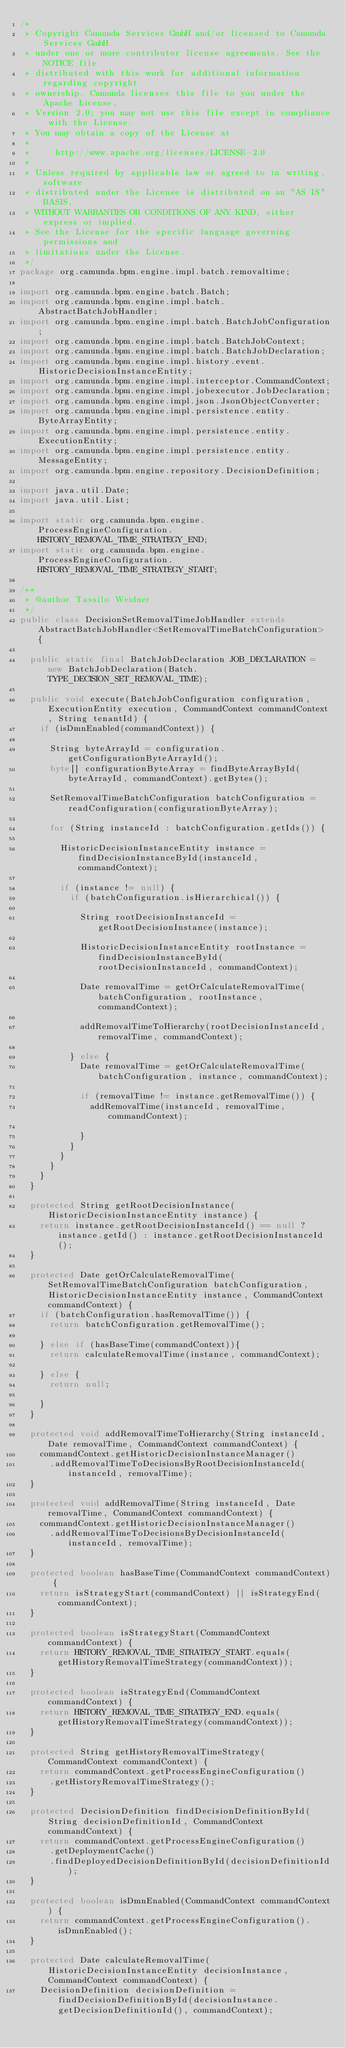Convert code to text. <code><loc_0><loc_0><loc_500><loc_500><_Java_>/*
 * Copyright Camunda Services GmbH and/or licensed to Camunda Services GmbH
 * under one or more contributor license agreements. See the NOTICE file
 * distributed with this work for additional information regarding copyright
 * ownership. Camunda licenses this file to you under the Apache License,
 * Version 2.0; you may not use this file except in compliance with the License.
 * You may obtain a copy of the License at
 *
 *     http://www.apache.org/licenses/LICENSE-2.0
 *
 * Unless required by applicable law or agreed to in writing, software
 * distributed under the License is distributed on an "AS IS" BASIS,
 * WITHOUT WARRANTIES OR CONDITIONS OF ANY KIND, either express or implied.
 * See the License for the specific language governing permissions and
 * limitations under the License.
 */
package org.camunda.bpm.engine.impl.batch.removaltime;

import org.camunda.bpm.engine.batch.Batch;
import org.camunda.bpm.engine.impl.batch.AbstractBatchJobHandler;
import org.camunda.bpm.engine.impl.batch.BatchJobConfiguration;
import org.camunda.bpm.engine.impl.batch.BatchJobContext;
import org.camunda.bpm.engine.impl.batch.BatchJobDeclaration;
import org.camunda.bpm.engine.impl.history.event.HistoricDecisionInstanceEntity;
import org.camunda.bpm.engine.impl.interceptor.CommandContext;
import org.camunda.bpm.engine.impl.jobexecutor.JobDeclaration;
import org.camunda.bpm.engine.impl.json.JsonObjectConverter;
import org.camunda.bpm.engine.impl.persistence.entity.ByteArrayEntity;
import org.camunda.bpm.engine.impl.persistence.entity.ExecutionEntity;
import org.camunda.bpm.engine.impl.persistence.entity.MessageEntity;
import org.camunda.bpm.engine.repository.DecisionDefinition;

import java.util.Date;
import java.util.List;

import static org.camunda.bpm.engine.ProcessEngineConfiguration.HISTORY_REMOVAL_TIME_STRATEGY_END;
import static org.camunda.bpm.engine.ProcessEngineConfiguration.HISTORY_REMOVAL_TIME_STRATEGY_START;

/**
 * @author Tassilo Weidner
 */
public class DecisionSetRemovalTimeJobHandler extends AbstractBatchJobHandler<SetRemovalTimeBatchConfiguration> {

  public static final BatchJobDeclaration JOB_DECLARATION = new BatchJobDeclaration(Batch.TYPE_DECISION_SET_REMOVAL_TIME);

  public void execute(BatchJobConfiguration configuration, ExecutionEntity execution, CommandContext commandContext, String tenantId) {
    if (isDmnEnabled(commandContext)) {

      String byteArrayId = configuration.getConfigurationByteArrayId();
      byte[] configurationByteArray = findByteArrayById(byteArrayId, commandContext).getBytes();

      SetRemovalTimeBatchConfiguration batchConfiguration = readConfiguration(configurationByteArray);

      for (String instanceId : batchConfiguration.getIds()) {

        HistoricDecisionInstanceEntity instance = findDecisionInstanceById(instanceId, commandContext);

        if (instance != null) {
          if (batchConfiguration.isHierarchical()) {

            String rootDecisionInstanceId = getRootDecisionInstance(instance);

            HistoricDecisionInstanceEntity rootInstance = findDecisionInstanceById(rootDecisionInstanceId, commandContext);

            Date removalTime = getOrCalculateRemovalTime(batchConfiguration, rootInstance, commandContext);

            addRemovalTimeToHierarchy(rootDecisionInstanceId, removalTime, commandContext);

          } else {
            Date removalTime = getOrCalculateRemovalTime(batchConfiguration, instance, commandContext);

            if (removalTime != instance.getRemovalTime()) {
              addRemovalTime(instanceId, removalTime, commandContext);

            }
          }
        }
      }
    }
  }

  protected String getRootDecisionInstance(HistoricDecisionInstanceEntity instance) {
    return instance.getRootDecisionInstanceId() == null ? instance.getId() : instance.getRootDecisionInstanceId();
  }

  protected Date getOrCalculateRemovalTime(SetRemovalTimeBatchConfiguration batchConfiguration, HistoricDecisionInstanceEntity instance, CommandContext commandContext) {
    if (batchConfiguration.hasRemovalTime()) {
      return batchConfiguration.getRemovalTime();

    } else if (hasBaseTime(commandContext)){
      return calculateRemovalTime(instance, commandContext);

    } else {
      return null;

    }
  }

  protected void addRemovalTimeToHierarchy(String instanceId, Date removalTime, CommandContext commandContext) {
    commandContext.getHistoricDecisionInstanceManager()
      .addRemovalTimeToDecisionsByRootDecisionInstanceId(instanceId, removalTime);
  }

  protected void addRemovalTime(String instanceId, Date removalTime, CommandContext commandContext) {
    commandContext.getHistoricDecisionInstanceManager()
      .addRemovalTimeToDecisionsByDecisionInstanceId(instanceId, removalTime);
  }

  protected boolean hasBaseTime(CommandContext commandContext) {
    return isStrategyStart(commandContext) || isStrategyEnd(commandContext);
  }

  protected boolean isStrategyStart(CommandContext commandContext) {
    return HISTORY_REMOVAL_TIME_STRATEGY_START.equals(getHistoryRemovalTimeStrategy(commandContext));
  }

  protected boolean isStrategyEnd(CommandContext commandContext) {
    return HISTORY_REMOVAL_TIME_STRATEGY_END.equals(getHistoryRemovalTimeStrategy(commandContext));
  }

  protected String getHistoryRemovalTimeStrategy(CommandContext commandContext) {
    return commandContext.getProcessEngineConfiguration()
      .getHistoryRemovalTimeStrategy();
  }

  protected DecisionDefinition findDecisionDefinitionById(String decisionDefinitionId, CommandContext commandContext) {
    return commandContext.getProcessEngineConfiguration()
      .getDeploymentCache()
      .findDeployedDecisionDefinitionById(decisionDefinitionId);
  }

  protected boolean isDmnEnabled(CommandContext commandContext) {
    return commandContext.getProcessEngineConfiguration().isDmnEnabled();
  }

  protected Date calculateRemovalTime(HistoricDecisionInstanceEntity decisionInstance, CommandContext commandContext) {
    DecisionDefinition decisionDefinition = findDecisionDefinitionById(decisionInstance.getDecisionDefinitionId(), commandContext);
</code> 